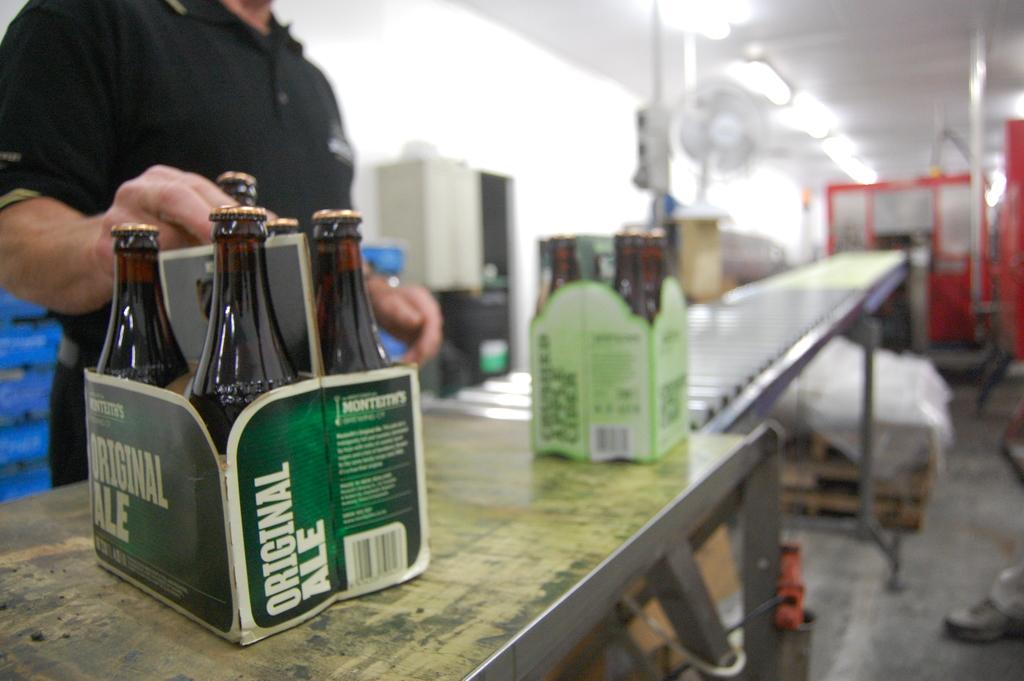What type of ale does this box claim to be?
Keep it short and to the point. Original. What is the brand of this ale?
Your response must be concise. Original ale. 